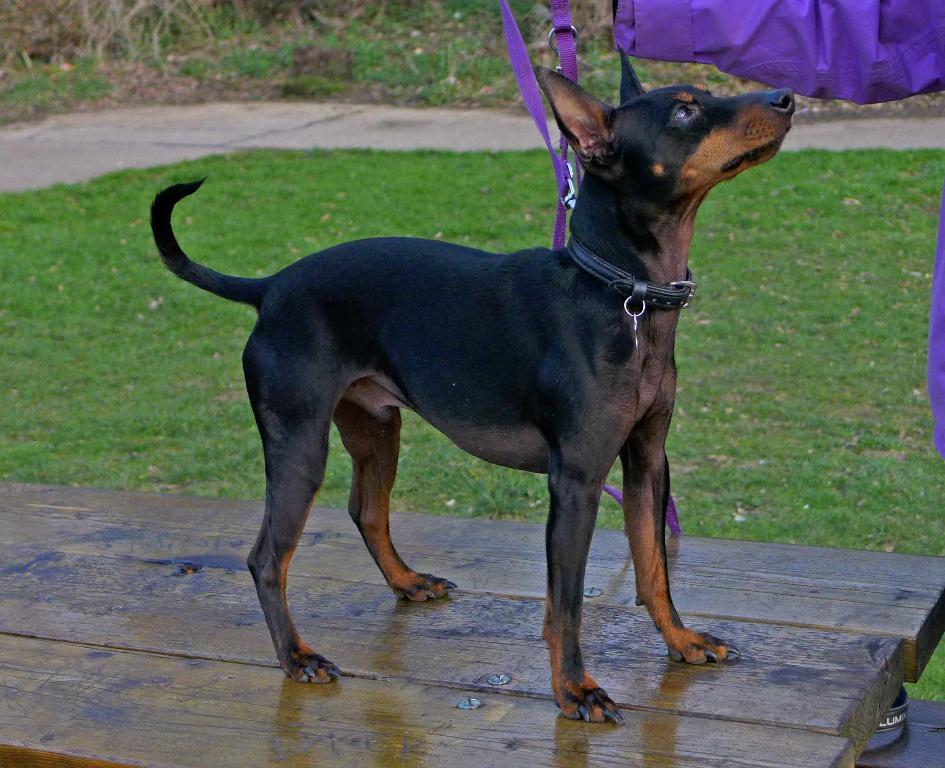What animal is on the wooden surface in the image? There is a dog on a wooden surface in the image. What can be seen on the right side of the image? There is some cloth on the right side of the image. What type of surface is visible beneath the wooden surface? The ground is visible in the image. What type of vegetation is present in the image? There is grass and plants in the image. What parent is shown interacting with the dog in the image? There is no parent present in the image; it only features a dog on a wooden surface. What force is being applied to the dog in the image? There is no force being applied to the dog in the image; it is simply sitting on the wooden surface. 